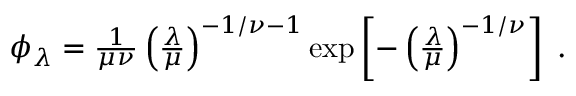<formula> <loc_0><loc_0><loc_500><loc_500>\begin{array} { r } { \phi _ { \lambda } = \frac { 1 } { \mu \nu } \left ( \frac { \lambda } { \mu } \right ) ^ { - 1 / \nu - 1 } \exp \left [ - \left ( \frac { \lambda } { \mu } \right ) ^ { - 1 / \nu } \right ] \, . } \end{array}</formula> 